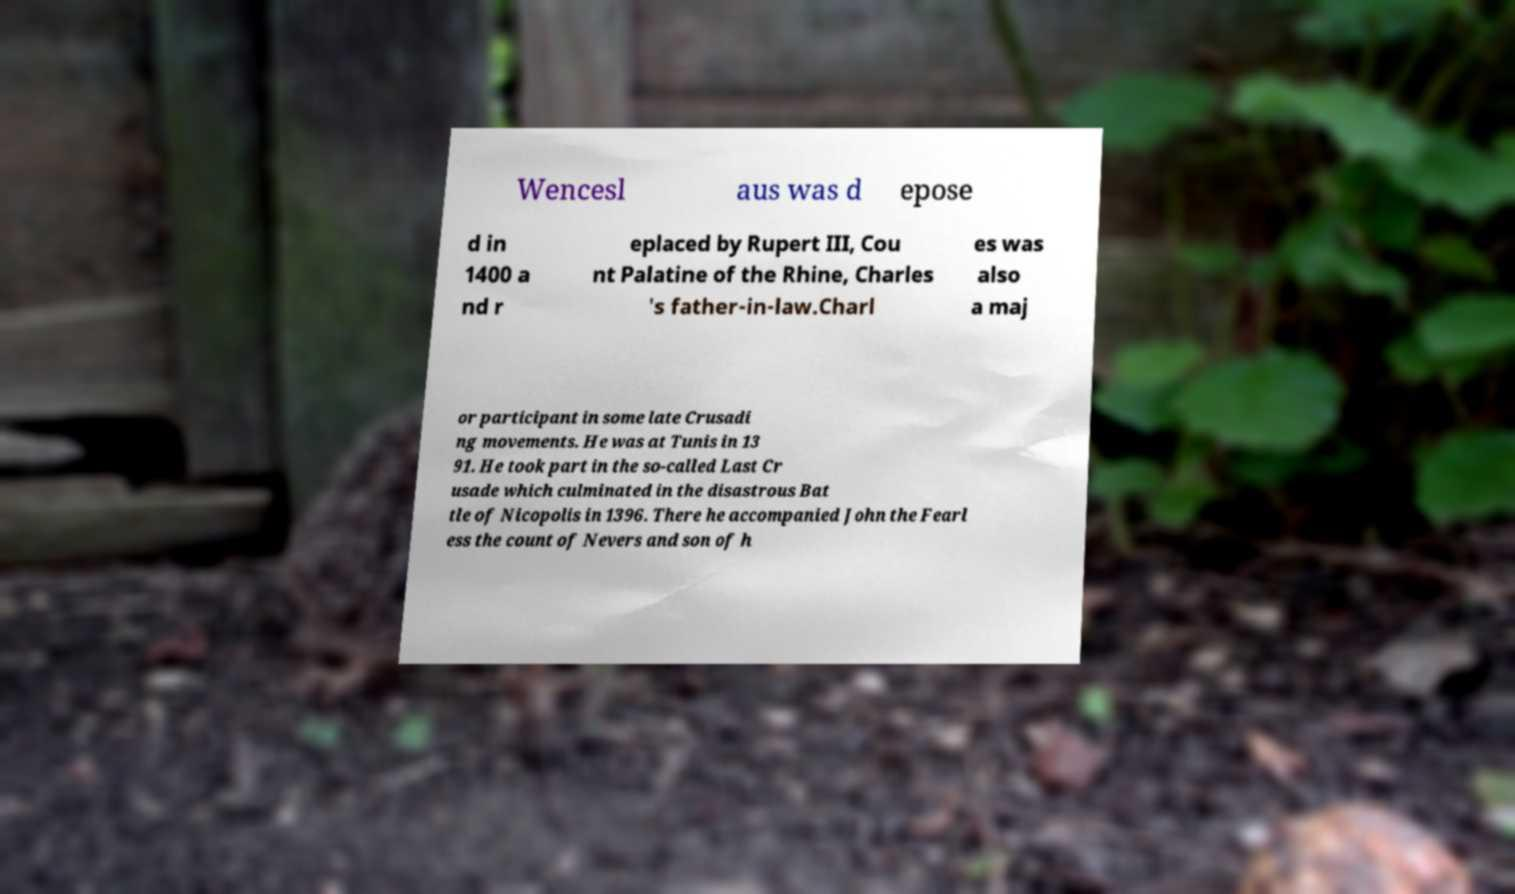Could you assist in decoding the text presented in this image and type it out clearly? Wencesl aus was d epose d in 1400 a nd r eplaced by Rupert III, Cou nt Palatine of the Rhine, Charles 's father-in-law.Charl es was also a maj or participant in some late Crusadi ng movements. He was at Tunis in 13 91. He took part in the so-called Last Cr usade which culminated in the disastrous Bat tle of Nicopolis in 1396. There he accompanied John the Fearl ess the count of Nevers and son of h 